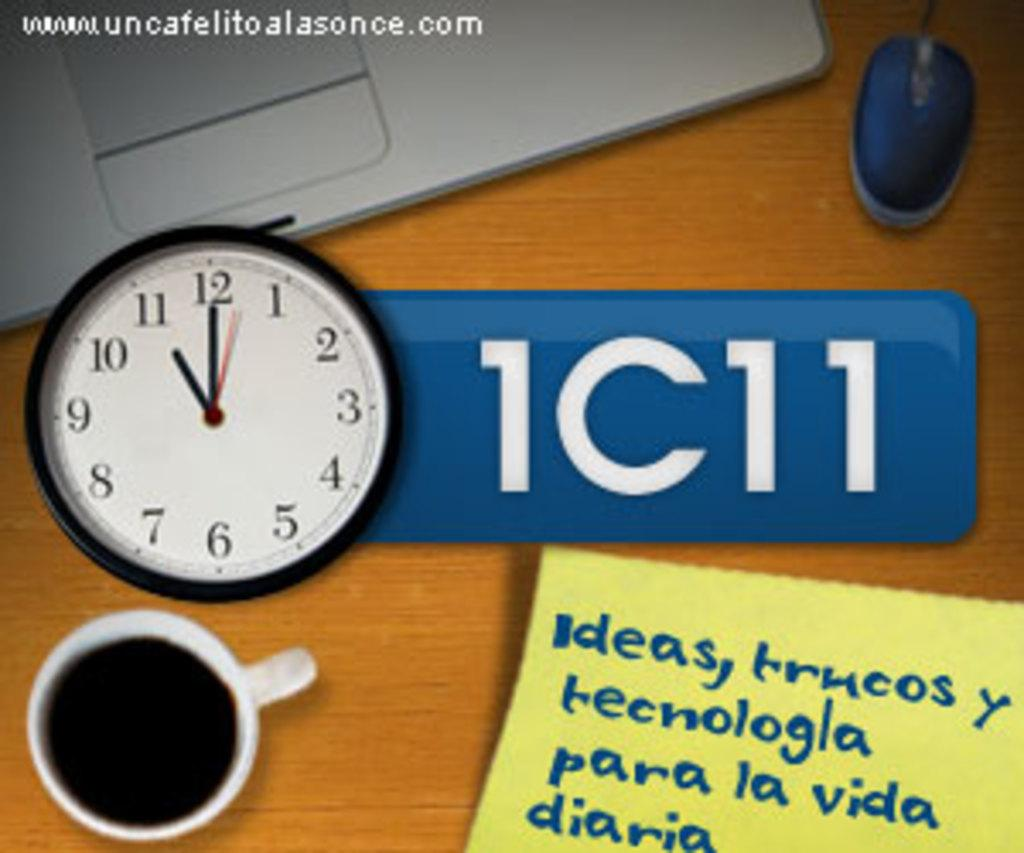<image>
Write a terse but informative summary of the picture. A person's desk that has a clock, a cup of coffee, and notes to remind them of ideas is set up. 